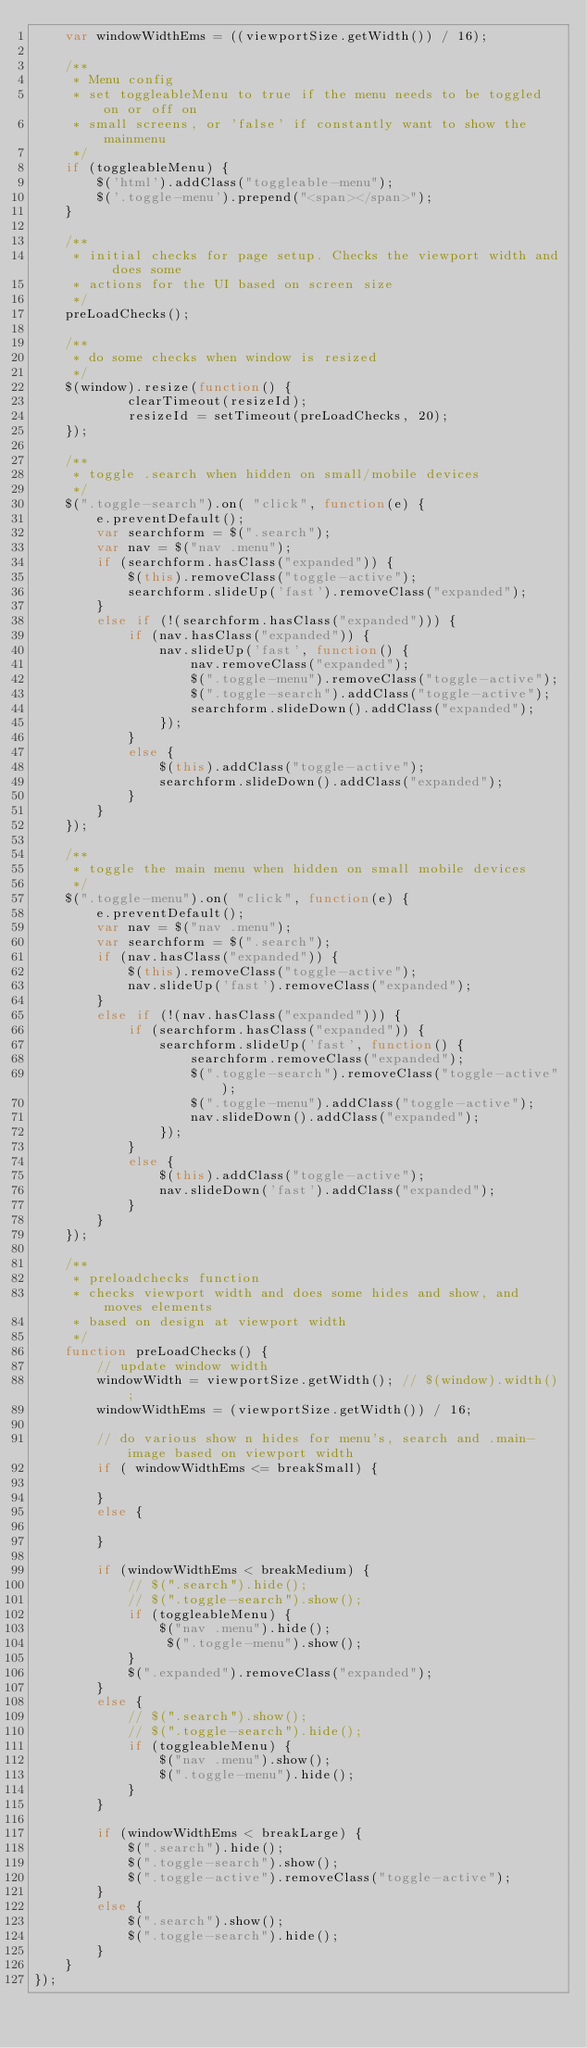Convert code to text. <code><loc_0><loc_0><loc_500><loc_500><_JavaScript_>    var windowWidthEms = ((viewportSize.getWidth()) / 16);

    /**
     * Menu config
     * set toggleableMenu to true if the menu needs to be toggled on or off on 
     * small screens, or 'false' if constantly want to show the mainmenu
     */
    if (toggleableMenu) {
        $('html').addClass("toggleable-menu");
        $('.toggle-menu').prepend("<span></span>");
    }

    /**
     * initial checks for page setup. Checks the viewport width and does some 
     * actions for the UI based on screen size
     */
    preLoadChecks();

    /**
     * do some checks when window is resized
     */
    $(window).resize(function() {       
            clearTimeout(resizeId);
            resizeId = setTimeout(preLoadChecks, 20);
    });

    /**
     * toggle .search when hidden on small/mobile devices
     */
    $(".toggle-search").on( "click", function(e) {
        e.preventDefault();
        var searchform = $(".search");
        var nav = $("nav .menu");
        if (searchform.hasClass("expanded")) {
            $(this).removeClass("toggle-active");
            searchform.slideUp('fast').removeClass("expanded");
        }
        else if (!(searchform.hasClass("expanded"))) {
            if (nav.hasClass("expanded")) {
                nav.slideUp('fast', function() {
                    nav.removeClass("expanded");
                    $(".toggle-menu").removeClass("toggle-active");
                    $(".toggle-search").addClass("toggle-active");
                    searchform.slideDown().addClass("expanded");
                });             
            }
            else {
                $(this).addClass("toggle-active");
                searchform.slideDown().addClass("expanded");
            }
        }
    });

    /**
     * toggle the main menu when hidden on small mobile devices
     */
    $(".toggle-menu").on( "click", function(e) {
        e.preventDefault();
        var nav = $("nav .menu");
        var searchform = $(".search");
        if (nav.hasClass("expanded")) {
            $(this).removeClass("toggle-active");
            nav.slideUp('fast').removeClass("expanded");
        }
        else if (!(nav.hasClass("expanded"))) {
            if (searchform.hasClass("expanded")) {
                searchform.slideUp('fast', function() {
                    searchform.removeClass("expanded");
                    $(".toggle-search").removeClass("toggle-active");
                    $(".toggle-menu").addClass("toggle-active");
                    nav.slideDown().addClass("expanded");
                });
            }
            else {
                $(this).addClass("toggle-active");
                nav.slideDown('fast').addClass("expanded");
            }
        }
    });

    /**
     * preloadchecks function
     * checks viewport width and does some hides and show, and moves elements
     * based on design at viewport width
     */
    function preLoadChecks() {
        // update window width
        windowWidth = viewportSize.getWidth(); // $(window).width();
        windowWidthEms = (viewportSize.getWidth()) / 16;

        // do various show n hides for menu's, search and .main-image based on viewport width
        if ( windowWidthEms <= breakSmall) { 

        }
        else {

        }

        if (windowWidthEms < breakMedium) {
            // $(".search").hide();
            // $(".toggle-search").show(); 
            if (toggleableMenu) {
                $("nav .menu").hide();
                 $(".toggle-menu").show();
            }
            $(".expanded").removeClass("expanded");
        }
        else {
            // $(".search").show();
            // $(".toggle-search").hide(); 
            if (toggleableMenu) {
                $("nav .menu").show();
                $(".toggle-menu").hide();
            }
        }

        if (windowWidthEms < breakLarge) {
            $(".search").hide();
            $(".toggle-search").show(); 
            $(".toggle-active").removeClass("toggle-active");
        }
        else {
            $(".search").show();
            $(".toggle-search").hide(); 
        }
    }   
});</code> 